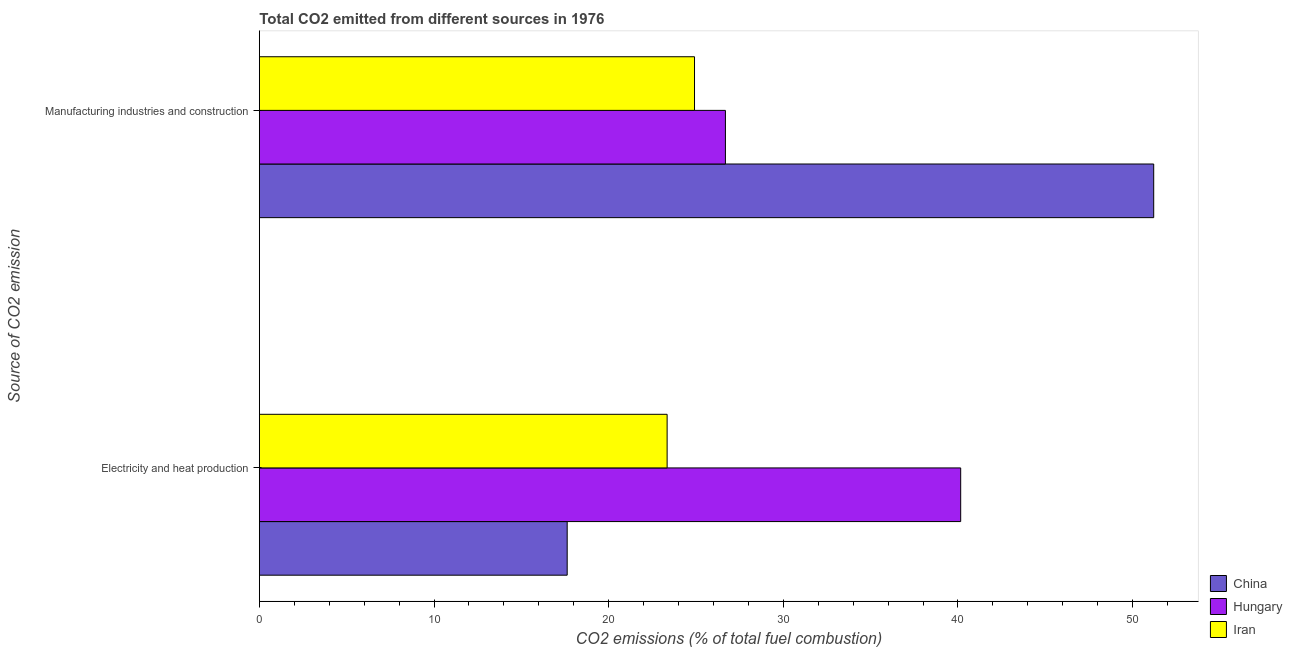How many different coloured bars are there?
Your response must be concise. 3. How many groups of bars are there?
Make the answer very short. 2. Are the number of bars per tick equal to the number of legend labels?
Offer a very short reply. Yes. Are the number of bars on each tick of the Y-axis equal?
Offer a very short reply. Yes. How many bars are there on the 2nd tick from the top?
Offer a terse response. 3. What is the label of the 2nd group of bars from the top?
Ensure brevity in your answer.  Electricity and heat production. What is the co2 emissions due to electricity and heat production in China?
Offer a very short reply. 17.63. Across all countries, what is the maximum co2 emissions due to electricity and heat production?
Make the answer very short. 40.16. Across all countries, what is the minimum co2 emissions due to electricity and heat production?
Offer a terse response. 17.63. In which country was the co2 emissions due to electricity and heat production maximum?
Make the answer very short. Hungary. In which country was the co2 emissions due to electricity and heat production minimum?
Provide a succinct answer. China. What is the total co2 emissions due to electricity and heat production in the graph?
Your answer should be very brief. 81.13. What is the difference between the co2 emissions due to electricity and heat production in Iran and that in Hungary?
Offer a terse response. -16.81. What is the difference between the co2 emissions due to manufacturing industries in Iran and the co2 emissions due to electricity and heat production in China?
Your answer should be very brief. 7.29. What is the average co2 emissions due to manufacturing industries per country?
Give a very brief answer. 34.27. What is the difference between the co2 emissions due to electricity and heat production and co2 emissions due to manufacturing industries in Hungary?
Keep it short and to the point. 13.47. What is the ratio of the co2 emissions due to electricity and heat production in China to that in Iran?
Your answer should be very brief. 0.75. Is the co2 emissions due to manufacturing industries in China less than that in Hungary?
Make the answer very short. No. What does the 2nd bar from the top in Manufacturing industries and construction represents?
Keep it short and to the point. Hungary. What does the 2nd bar from the bottom in Electricity and heat production represents?
Provide a succinct answer. Hungary. How many countries are there in the graph?
Keep it short and to the point. 3. What is the difference between two consecutive major ticks on the X-axis?
Provide a short and direct response. 10. Does the graph contain any zero values?
Offer a terse response. No. Does the graph contain grids?
Provide a succinct answer. No. Where does the legend appear in the graph?
Ensure brevity in your answer.  Bottom right. How many legend labels are there?
Provide a succinct answer. 3. What is the title of the graph?
Your response must be concise. Total CO2 emitted from different sources in 1976. Does "High income: nonOECD" appear as one of the legend labels in the graph?
Give a very brief answer. No. What is the label or title of the X-axis?
Make the answer very short. CO2 emissions (% of total fuel combustion). What is the label or title of the Y-axis?
Your answer should be very brief. Source of CO2 emission. What is the CO2 emissions (% of total fuel combustion) in China in Electricity and heat production?
Your answer should be compact. 17.63. What is the CO2 emissions (% of total fuel combustion) in Hungary in Electricity and heat production?
Provide a succinct answer. 40.16. What is the CO2 emissions (% of total fuel combustion) of Iran in Electricity and heat production?
Give a very brief answer. 23.35. What is the CO2 emissions (% of total fuel combustion) in China in Manufacturing industries and construction?
Your answer should be very brief. 51.21. What is the CO2 emissions (% of total fuel combustion) of Hungary in Manufacturing industries and construction?
Offer a terse response. 26.69. What is the CO2 emissions (% of total fuel combustion) in Iran in Manufacturing industries and construction?
Provide a short and direct response. 24.92. Across all Source of CO2 emission, what is the maximum CO2 emissions (% of total fuel combustion) in China?
Offer a very short reply. 51.21. Across all Source of CO2 emission, what is the maximum CO2 emissions (% of total fuel combustion) of Hungary?
Provide a succinct answer. 40.16. Across all Source of CO2 emission, what is the maximum CO2 emissions (% of total fuel combustion) in Iran?
Offer a very short reply. 24.92. Across all Source of CO2 emission, what is the minimum CO2 emissions (% of total fuel combustion) of China?
Provide a short and direct response. 17.63. Across all Source of CO2 emission, what is the minimum CO2 emissions (% of total fuel combustion) in Hungary?
Make the answer very short. 26.69. Across all Source of CO2 emission, what is the minimum CO2 emissions (% of total fuel combustion) of Iran?
Ensure brevity in your answer.  23.35. What is the total CO2 emissions (% of total fuel combustion) of China in the graph?
Make the answer very short. 68.83. What is the total CO2 emissions (% of total fuel combustion) in Hungary in the graph?
Ensure brevity in your answer.  66.84. What is the total CO2 emissions (% of total fuel combustion) in Iran in the graph?
Make the answer very short. 48.26. What is the difference between the CO2 emissions (% of total fuel combustion) in China in Electricity and heat production and that in Manufacturing industries and construction?
Offer a very short reply. -33.58. What is the difference between the CO2 emissions (% of total fuel combustion) in Hungary in Electricity and heat production and that in Manufacturing industries and construction?
Offer a terse response. 13.47. What is the difference between the CO2 emissions (% of total fuel combustion) of Iran in Electricity and heat production and that in Manufacturing industries and construction?
Make the answer very short. -1.57. What is the difference between the CO2 emissions (% of total fuel combustion) of China in Electricity and heat production and the CO2 emissions (% of total fuel combustion) of Hungary in Manufacturing industries and construction?
Your response must be concise. -9.06. What is the difference between the CO2 emissions (% of total fuel combustion) of China in Electricity and heat production and the CO2 emissions (% of total fuel combustion) of Iran in Manufacturing industries and construction?
Make the answer very short. -7.29. What is the difference between the CO2 emissions (% of total fuel combustion) in Hungary in Electricity and heat production and the CO2 emissions (% of total fuel combustion) in Iran in Manufacturing industries and construction?
Your answer should be very brief. 15.24. What is the average CO2 emissions (% of total fuel combustion) in China per Source of CO2 emission?
Your answer should be very brief. 34.42. What is the average CO2 emissions (% of total fuel combustion) in Hungary per Source of CO2 emission?
Offer a terse response. 33.42. What is the average CO2 emissions (% of total fuel combustion) in Iran per Source of CO2 emission?
Give a very brief answer. 24.13. What is the difference between the CO2 emissions (% of total fuel combustion) of China and CO2 emissions (% of total fuel combustion) of Hungary in Electricity and heat production?
Your answer should be very brief. -22.53. What is the difference between the CO2 emissions (% of total fuel combustion) of China and CO2 emissions (% of total fuel combustion) of Iran in Electricity and heat production?
Your answer should be compact. -5.72. What is the difference between the CO2 emissions (% of total fuel combustion) in Hungary and CO2 emissions (% of total fuel combustion) in Iran in Electricity and heat production?
Your response must be concise. 16.81. What is the difference between the CO2 emissions (% of total fuel combustion) of China and CO2 emissions (% of total fuel combustion) of Hungary in Manufacturing industries and construction?
Make the answer very short. 24.52. What is the difference between the CO2 emissions (% of total fuel combustion) of China and CO2 emissions (% of total fuel combustion) of Iran in Manufacturing industries and construction?
Provide a short and direct response. 26.29. What is the difference between the CO2 emissions (% of total fuel combustion) in Hungary and CO2 emissions (% of total fuel combustion) in Iran in Manufacturing industries and construction?
Your answer should be very brief. 1.77. What is the ratio of the CO2 emissions (% of total fuel combustion) in China in Electricity and heat production to that in Manufacturing industries and construction?
Ensure brevity in your answer.  0.34. What is the ratio of the CO2 emissions (% of total fuel combustion) in Hungary in Electricity and heat production to that in Manufacturing industries and construction?
Offer a terse response. 1.5. What is the ratio of the CO2 emissions (% of total fuel combustion) in Iran in Electricity and heat production to that in Manufacturing industries and construction?
Your answer should be very brief. 0.94. What is the difference between the highest and the second highest CO2 emissions (% of total fuel combustion) of China?
Give a very brief answer. 33.58. What is the difference between the highest and the second highest CO2 emissions (% of total fuel combustion) in Hungary?
Your answer should be compact. 13.47. What is the difference between the highest and the second highest CO2 emissions (% of total fuel combustion) in Iran?
Give a very brief answer. 1.57. What is the difference between the highest and the lowest CO2 emissions (% of total fuel combustion) of China?
Offer a very short reply. 33.58. What is the difference between the highest and the lowest CO2 emissions (% of total fuel combustion) of Hungary?
Keep it short and to the point. 13.47. What is the difference between the highest and the lowest CO2 emissions (% of total fuel combustion) in Iran?
Provide a succinct answer. 1.57. 